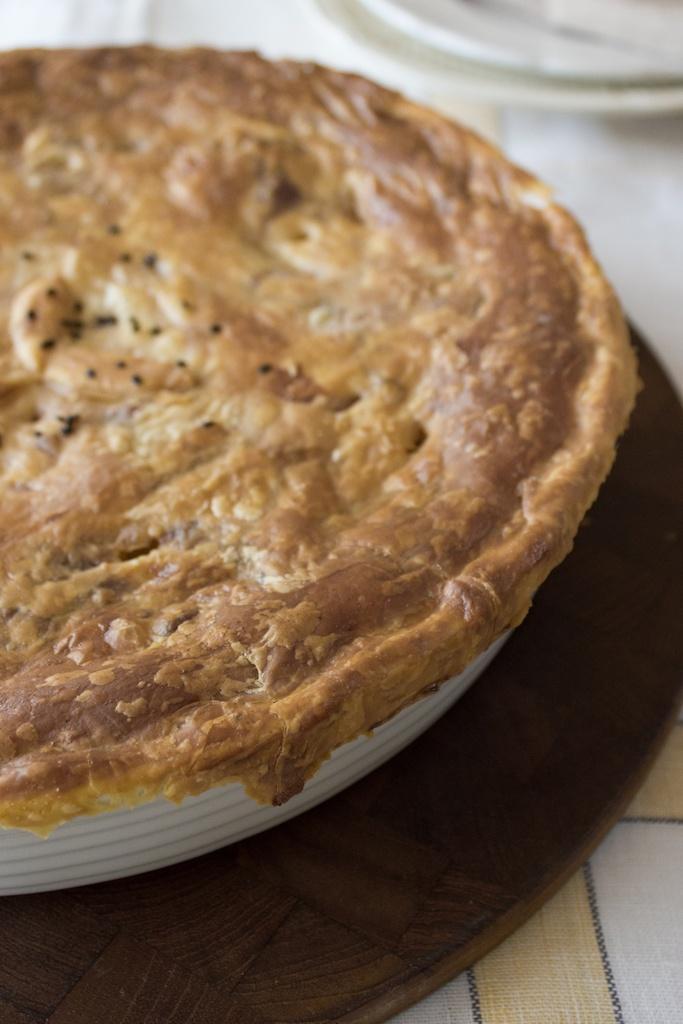Could you give a brief overview of what you see in this image? In the center of the image there is a food item in a plate. At the bottom of the image there is a table on which there is a cloth. 